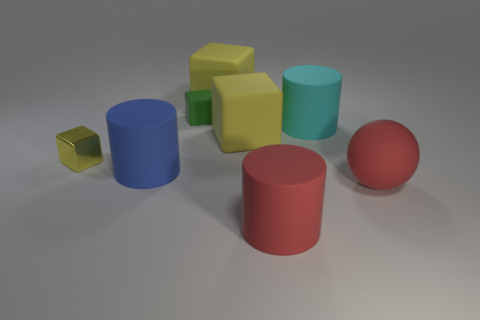What is the size of the cylinder behind the big matte object left of the green rubber block?
Ensure brevity in your answer.  Large. How many things are blue spheres or big yellow objects that are behind the small green cube?
Make the answer very short. 1. There is a large ball that is made of the same material as the small green cube; what is its color?
Provide a short and direct response. Red. How many large red spheres are made of the same material as the tiny green object?
Your answer should be compact. 1. How many blocks are there?
Keep it short and to the point. 4. Does the block that is on the left side of the blue cylinder have the same color as the big object behind the cyan rubber thing?
Give a very brief answer. Yes. How many tiny yellow shiny objects are left of the green cube?
Keep it short and to the point. 1. Are there any big blue things of the same shape as the cyan matte thing?
Provide a succinct answer. Yes. Is the material of the cylinder that is to the left of the big red cylinder the same as the tiny block in front of the large cyan matte thing?
Offer a terse response. No. What is the size of the cube left of the green block behind the big object that is in front of the large ball?
Provide a short and direct response. Small. 